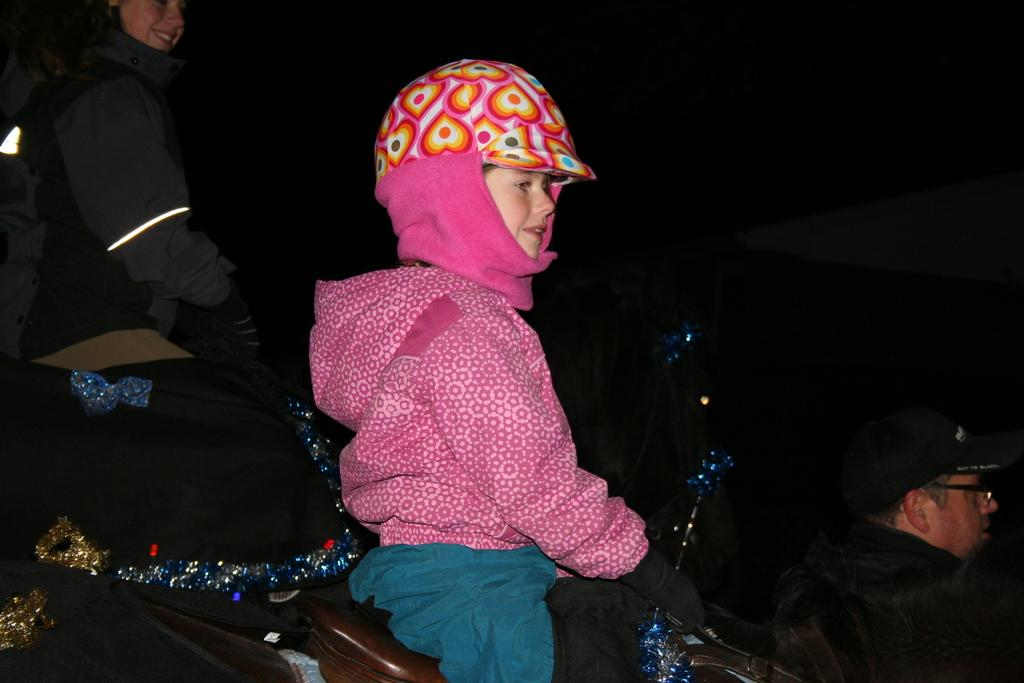How many people are in the image? There are three people in the image. What accessories are some of the people wearing? Some of the people are wearing caps, spectacles, gloves, and jackets. What can be seen in the image besides the people? There are clothes and objects visible in the image. What expressions do some of the people have? Two people are smiling in the image. How would you describe the background of the image? The background of the image is dark. What news is being reported by the person holding a hammer in the image? There is no person holding a hammer in the image, nor is there any news being reported. What type of shock can be seen affecting the person in the image? There is no shock or any indication of shock affecting any person in the image. 